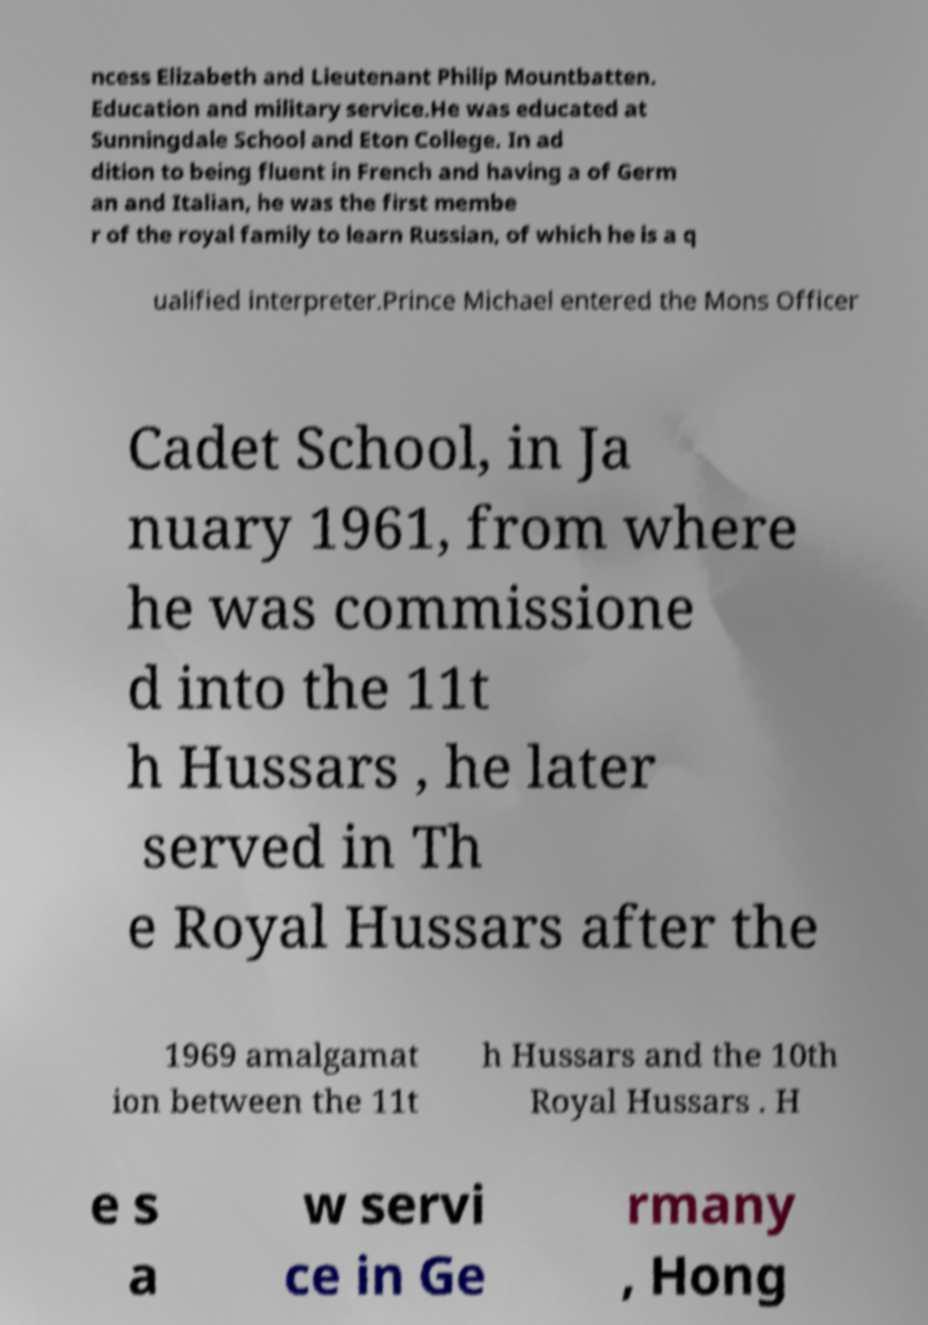Can you accurately transcribe the text from the provided image for me? ncess Elizabeth and Lieutenant Philip Mountbatten. Education and military service.He was educated at Sunningdale School and Eton College. In ad dition to being fluent in French and having a of Germ an and Italian, he was the first membe r of the royal family to learn Russian, of which he is a q ualified interpreter.Prince Michael entered the Mons Officer Cadet School, in Ja nuary 1961, from where he was commissione d into the 11t h Hussars , he later served in Th e Royal Hussars after the 1969 amalgamat ion between the 11t h Hussars and the 10th Royal Hussars . H e s a w servi ce in Ge rmany , Hong 